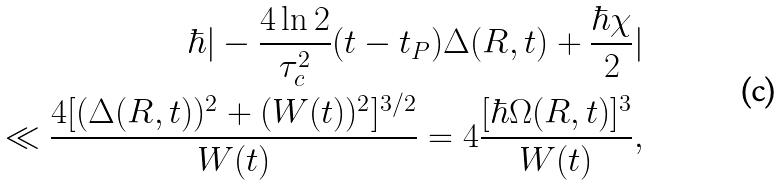<formula> <loc_0><loc_0><loc_500><loc_500>\hbar { | } - \frac { 4 \ln 2 } { \tau _ { c } ^ { 2 } } ( t - t _ { P } ) \Delta ( R , t ) + \frac { \hbar { \chi } } { 2 } | \\ \ll \frac { 4 [ ( \Delta ( R , t ) ) ^ { 2 } + ( W ( t ) ) ^ { 2 } ] ^ { 3 / 2 } } { W ( t ) } = 4 \frac { [ \hbar { \Omega } ( R , t ) ] ^ { 3 } } { W ( t ) } ,</formula> 